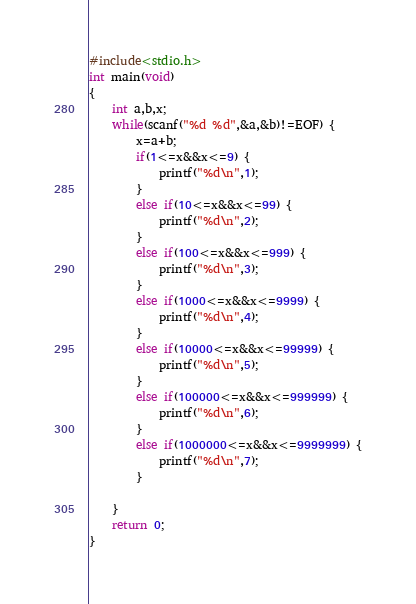Convert code to text. <code><loc_0><loc_0><loc_500><loc_500><_C_>#include<stdio.h>
int main(void)
{
	int a,b,x;
	while(scanf("%d %d",&a,&b)!=EOF) {
		x=a+b;
		if(1<=x&&x<=9) {
			printf("%d\n",1);
		}
		else if(10<=x&&x<=99) {
			printf("%d\n",2);
		}
		else if(100<=x&&x<=999) {
			printf("%d\n",3);
		}
		else if(1000<=x&&x<=9999) {
			printf("%d\n",4);
		}
		else if(10000<=x&&x<=99999) {
			printf("%d\n",5);
		}
		else if(100000<=x&&x<=999999) {
			printf("%d\n",6);
		}
		else if(1000000<=x&&x<=9999999) {
			printf("%d\n",7);
		}
		
	}
	return 0;
}
</code> 